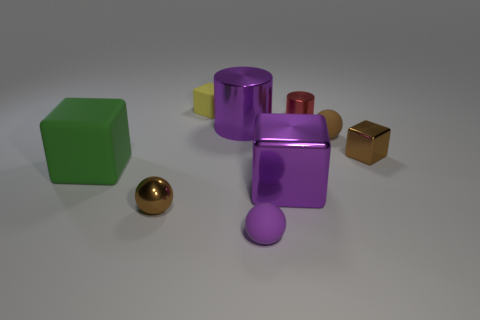What size is the purple thing behind the shiny block left of the block that is to the right of the tiny cylinder?
Provide a succinct answer. Large. What material is the small ball that is the same color as the large metal cylinder?
Offer a terse response. Rubber. What number of shiny things are brown objects or cyan cylinders?
Provide a short and direct response. 2. The brown cube has what size?
Your response must be concise. Small. How many things are tiny green cylinders or tiny yellow rubber objects behind the tiny brown metal cube?
Offer a terse response. 1. What number of other things are there of the same color as the big matte object?
Your response must be concise. 0. There is a brown metallic block; does it have the same size as the purple metallic thing that is on the right side of the tiny purple sphere?
Your answer should be compact. No. Is the size of the matte object that is to the right of the purple rubber thing the same as the large green rubber thing?
Ensure brevity in your answer.  No. What number of other objects are there of the same material as the large green object?
Give a very brief answer. 3. Are there the same number of tiny yellow rubber cubes right of the small purple matte object and brown balls that are right of the tiny yellow matte block?
Your response must be concise. No. 